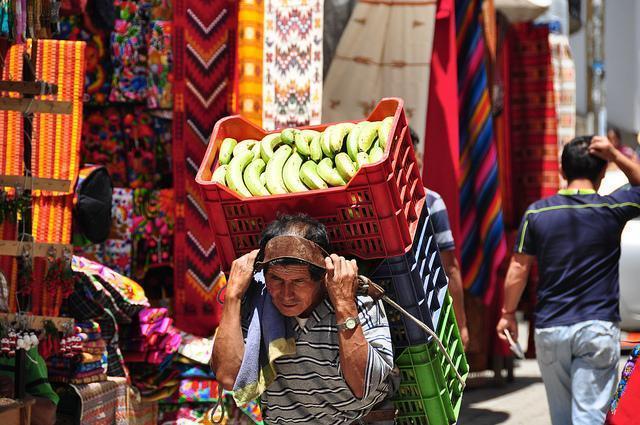How many people are in the picture?
Give a very brief answer. 3. 